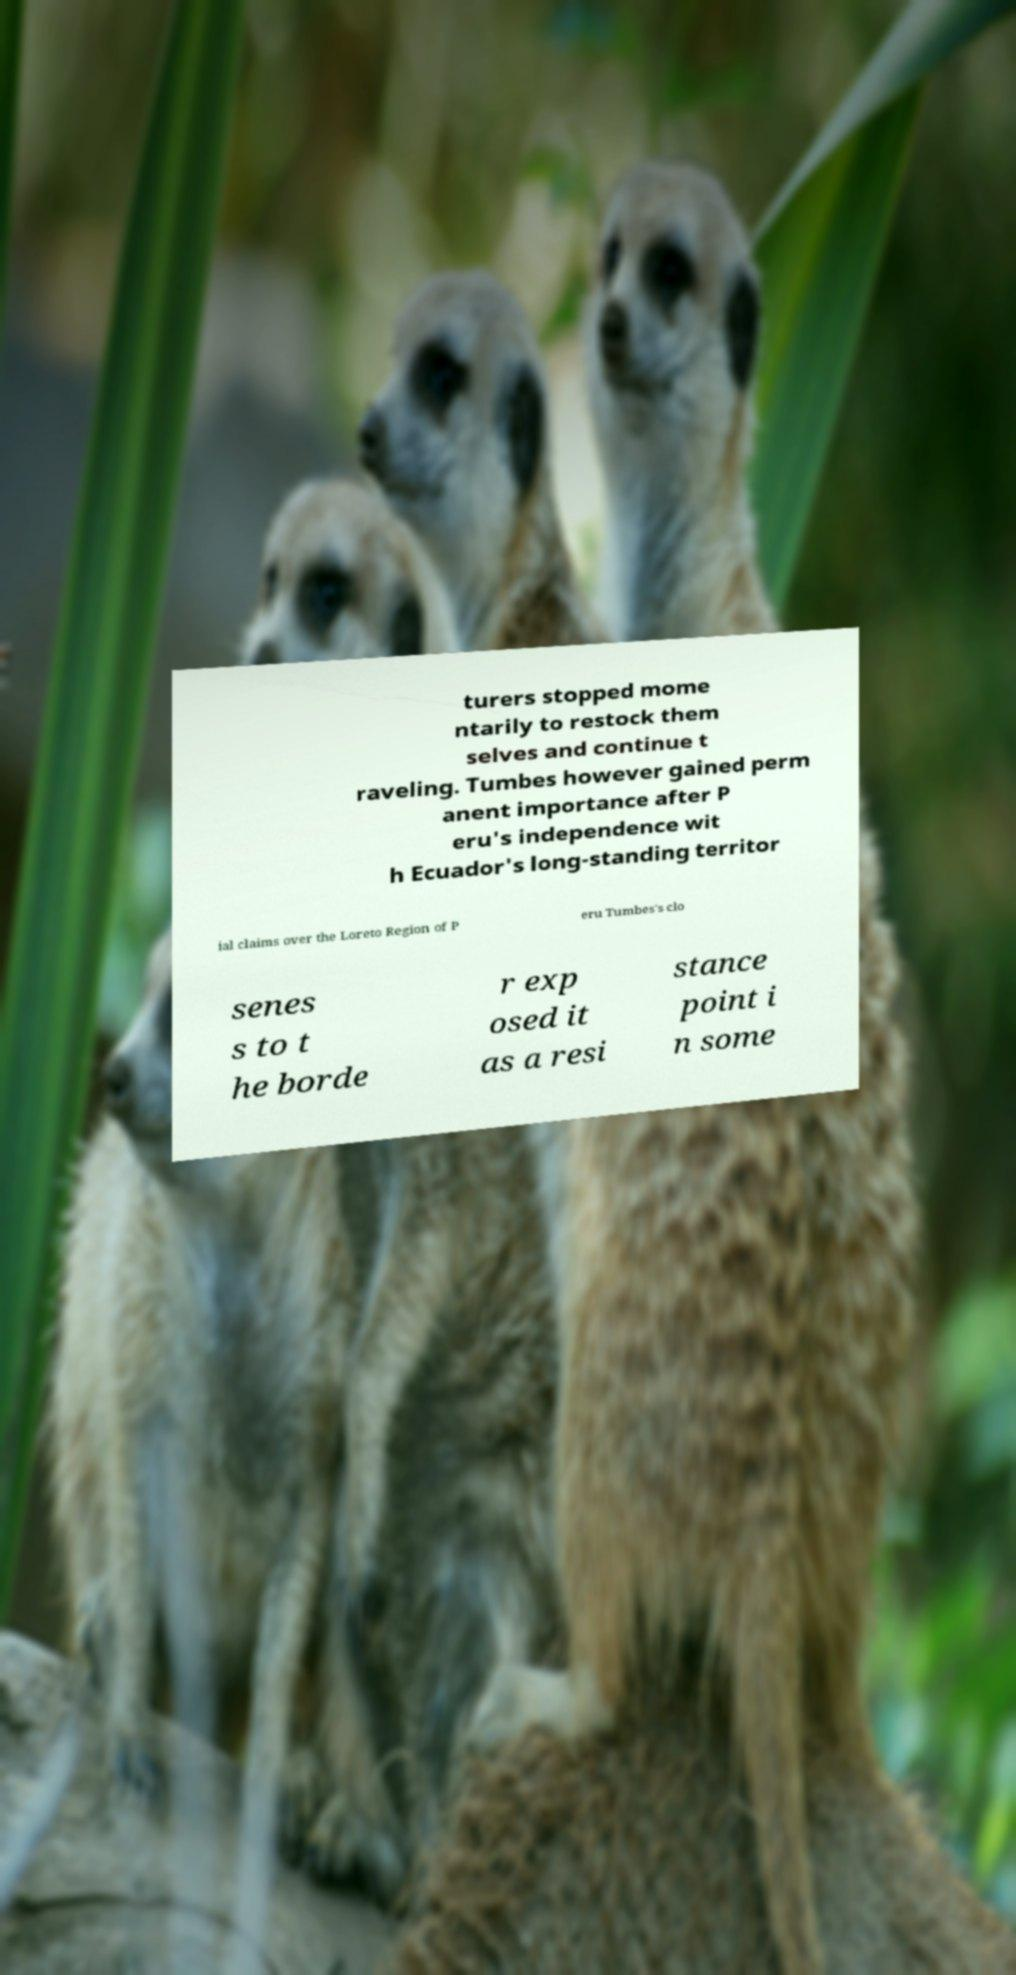For documentation purposes, I need the text within this image transcribed. Could you provide that? turers stopped mome ntarily to restock them selves and continue t raveling. Tumbes however gained perm anent importance after P eru's independence wit h Ecuador's long-standing territor ial claims over the Loreto Region of P eru Tumbes's clo senes s to t he borde r exp osed it as a resi stance point i n some 